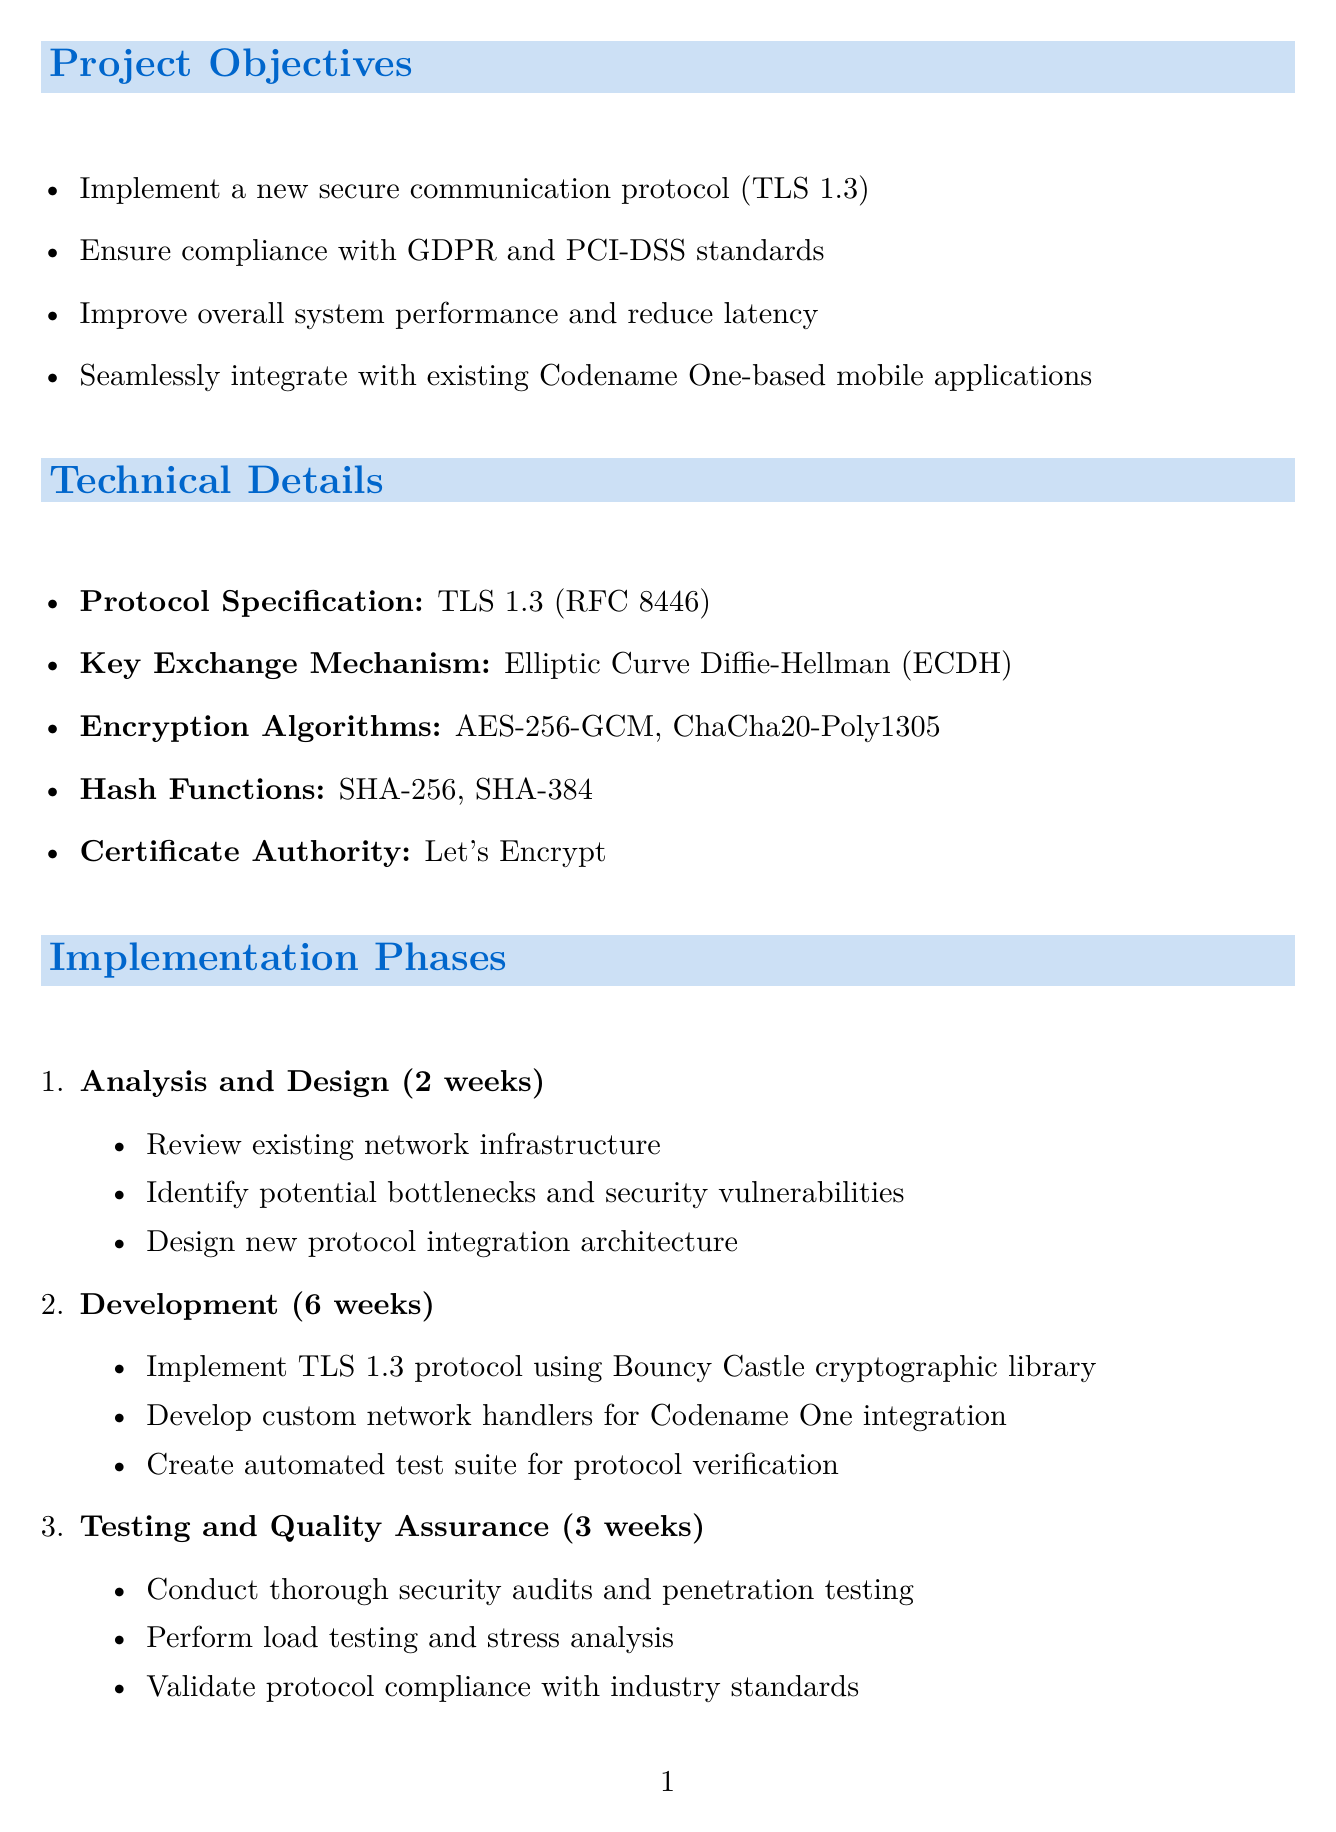what is the project title? The project title is stated at the beginning of the document as the title of the proposal.
Answer: Secure Communication Protocol Implementation for XYZ Corporation how many phases are there in the implementation? The document lists the phases of implementation clearly numbered, indicating how many there are.
Answer: 4 what is the total cost estimate for the project? The total cost estimate is summarized in the budget section of the document.
Answer: $150,000 what is the key exchange mechanism proposed? The document specifies the key exchange mechanism in the technical details section.
Answer: Elliptic Curve Diffie-Hellman (ECDH) when is the project scheduled to start? The timeline section of the document clearly states the project start date.
Answer: July 1, 2023 who is responsible for protocol design and security implementation? The team composition outlines roles and responsibilities of each team member.
Answer: Senior Network Security Engineer what encryption algorithms are being used? The technical details section lists the encryption algorithms proposed for the new protocol.
Answer: AES-256-GCM, ChaCha20-Poly1305 what is the mitigation strategy for compatibility issues? The risk assessment section provides mitigation strategies for identified risks, including compatibility issues.
Answer: Thorough testing and fallback mechanisms 